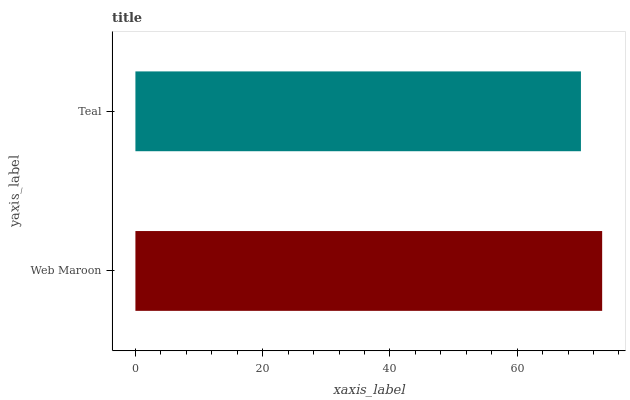Is Teal the minimum?
Answer yes or no. Yes. Is Web Maroon the maximum?
Answer yes or no. Yes. Is Teal the maximum?
Answer yes or no. No. Is Web Maroon greater than Teal?
Answer yes or no. Yes. Is Teal less than Web Maroon?
Answer yes or no. Yes. Is Teal greater than Web Maroon?
Answer yes or no. No. Is Web Maroon less than Teal?
Answer yes or no. No. Is Web Maroon the high median?
Answer yes or no. Yes. Is Teal the low median?
Answer yes or no. Yes. Is Teal the high median?
Answer yes or no. No. Is Web Maroon the low median?
Answer yes or no. No. 